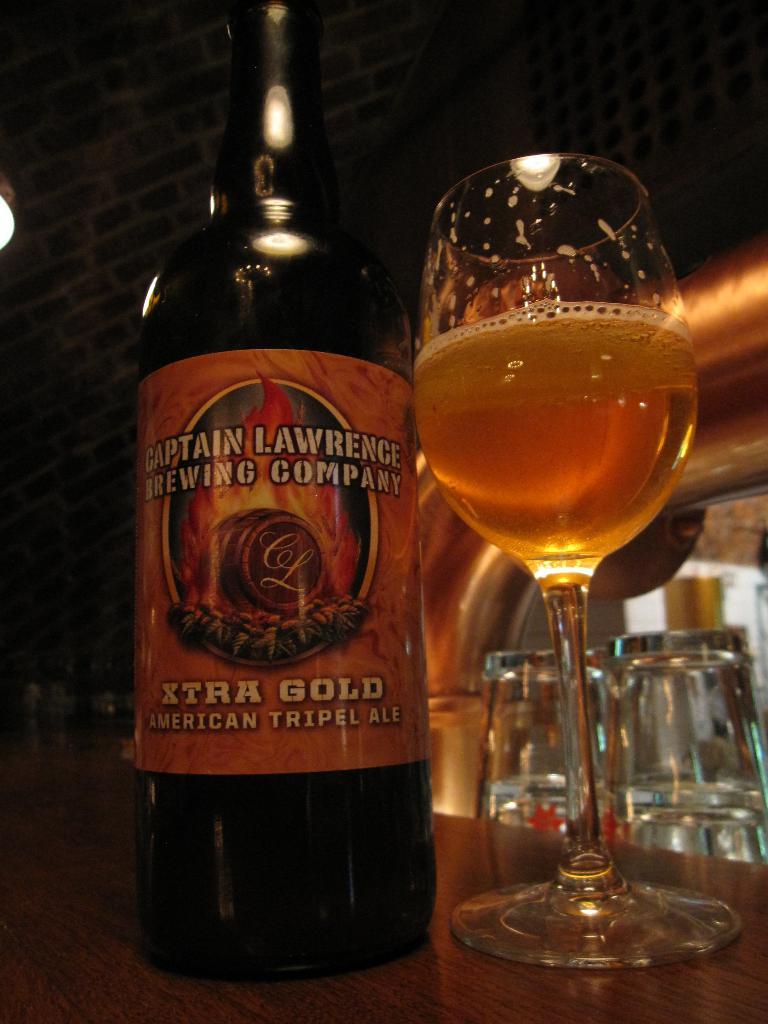What kind of drink is this?
Offer a terse response. American triple ale. What is the brand of this?
Your answer should be very brief. Captain lawrence brewing company. 